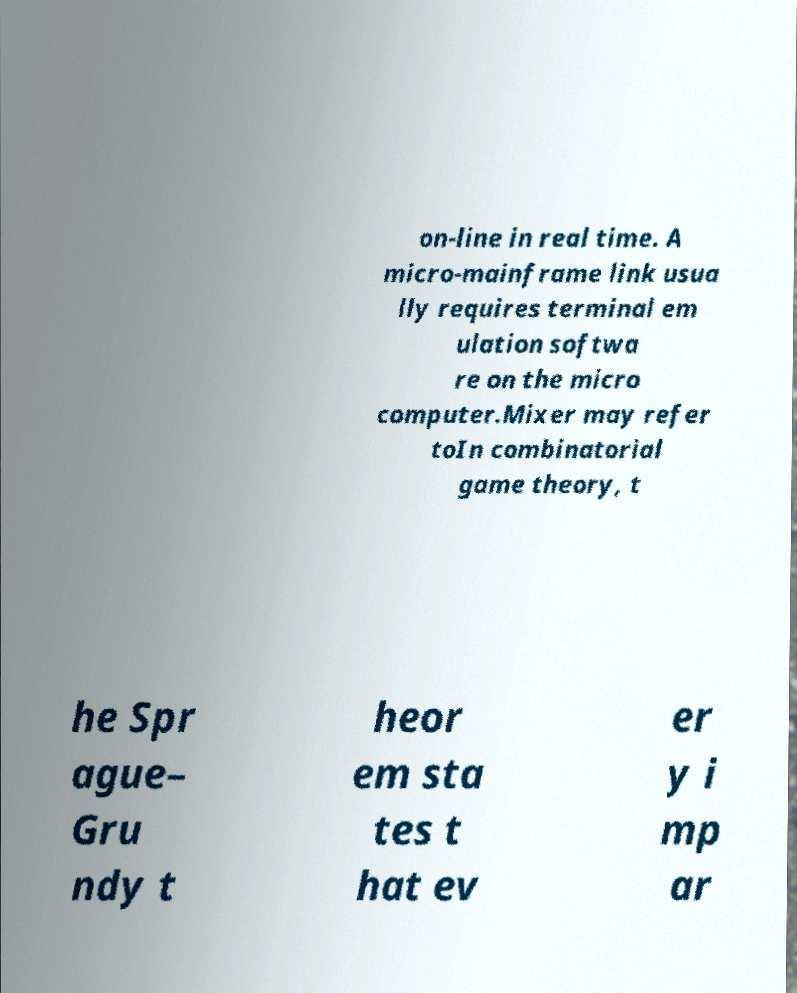I need the written content from this picture converted into text. Can you do that? on-line in real time. A micro-mainframe link usua lly requires terminal em ulation softwa re on the micro computer.Mixer may refer toIn combinatorial game theory, t he Spr ague– Gru ndy t heor em sta tes t hat ev er y i mp ar 